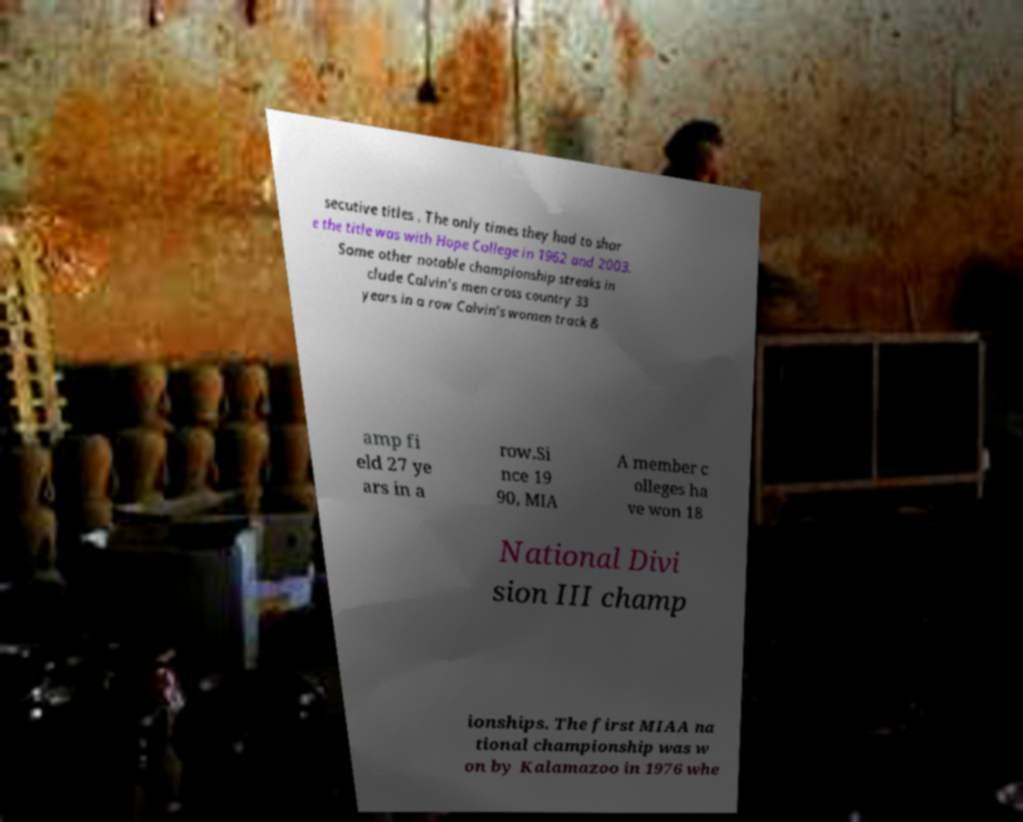Could you assist in decoding the text presented in this image and type it out clearly? secutive titles . The only times they had to shar e the title was with Hope College in 1962 and 2003. Some other notable championship streaks in clude Calvin's men cross country 33 years in a row Calvin's women track & amp fi eld 27 ye ars in a row.Si nce 19 90, MIA A member c olleges ha ve won 18 National Divi sion III champ ionships. The first MIAA na tional championship was w on by Kalamazoo in 1976 whe 